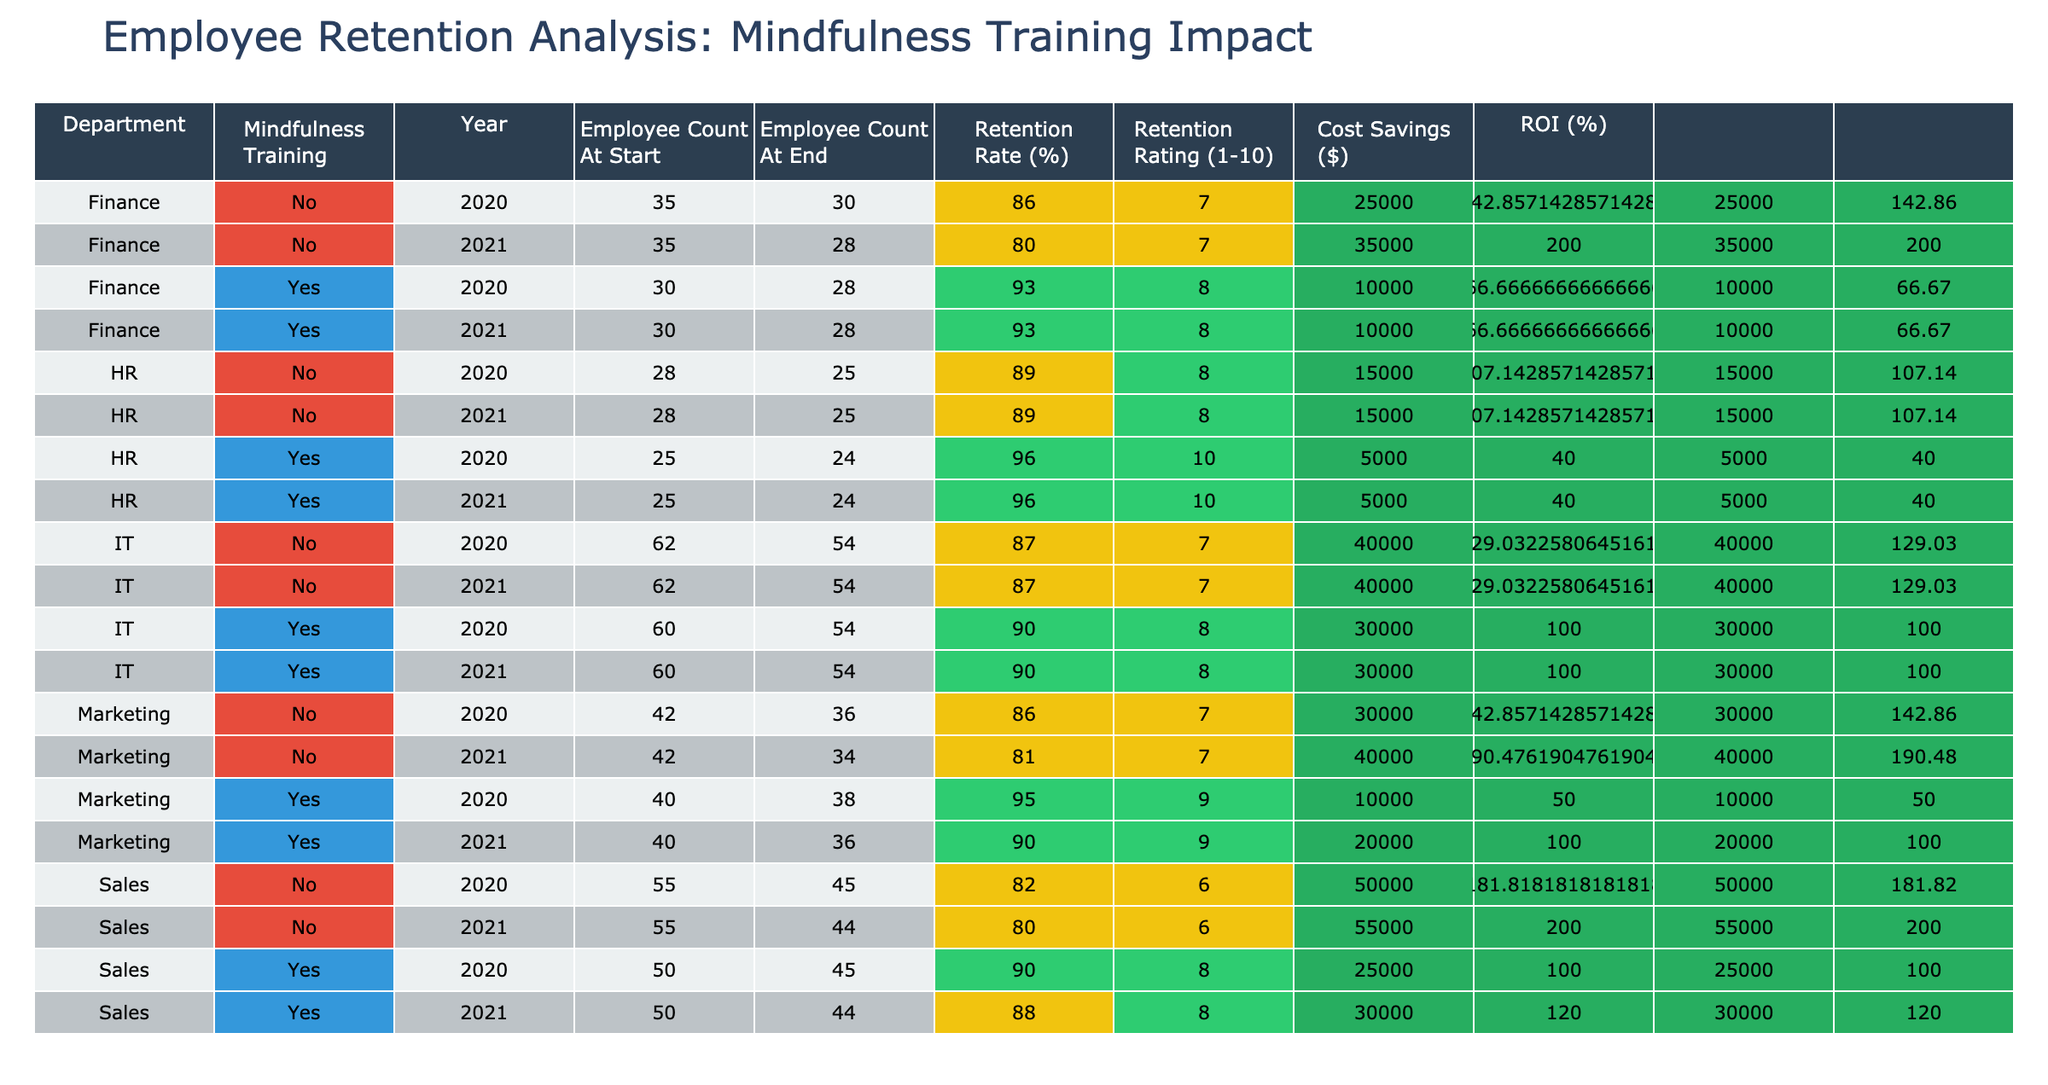What is the average retention rate for departments with mindfulness training in 2020? The retention rates for departments with mindfulness training in 2020 are 90 (Sales), 95 (Marketing), 93 (Finance), and 96 (HR). To find the average, we sum these values: 90 + 95 + 93 + 96 = 374. Then, we divide by the number of departments (4), resulting in 374 / 4 = 93.5
Answer: 93.5 What is the retention rate for the IT department in 2021? The retention rate for the IT department in 2021 is listed directly under 'Retention Rate (%)' for IT and 2021, which is 90.
Answer: 90 Which department had the highest retention rating in 2021? The retention ratings for 2021 are as follows: Sales (8), Marketing (9), Finance (8), HR (10), and IT (8). The highest value is HR with a rating of 10.
Answer: HR Was the retention rate higher or lower for the Sales department in 2021 compared to 2020? The retention rate for the Sales department in 2020 is 90% and in 2021 is 88%. Since 88 is less than 90, the retention rate is lower in 2021 compared to 2020.
Answer: Lower What is the total cost savings for departments with mindfulness training across both years? The cost savings for each department with mindfulness training are calculated as follows: Sales (25,000), Marketing (10,000), Finance (10,000), HR (5,000), and IT (30,000). Summing these: 25,000 + 10,000 + 10,000 + 5,000 + 30,000 = 80,000.
Answer: 80,000 What is the difference in average retention rate between departments with mindfulness training and those without in 2021? The average retention rate for departments with mindfulness training in 2021 is (88 + 90 + 93 + 96 + 90) / 5 = 91. The average for departments without training is (80 + 81 + 86 + 89) / 4 = 84.5. The difference is 91 - 84.5 = 6.5.
Answer: 6.5 Did the retention rate for the Finance department remain stable between 2020 and 2021? The retention rate for Finance in 2020 is 93% and in 2021 is also 93%. Since these values are equal, the retention rate remained stable.
Answer: Yes Which department with mindfulness training saw the greatest rate of employee retention in 2020? The employee retention rates for departments with mindfulness training in 2020 are: Sales (90), Marketing (95), Finance (93), and HR (96). The highest rate is in HR with a retention rate of 96.
Answer: HR 